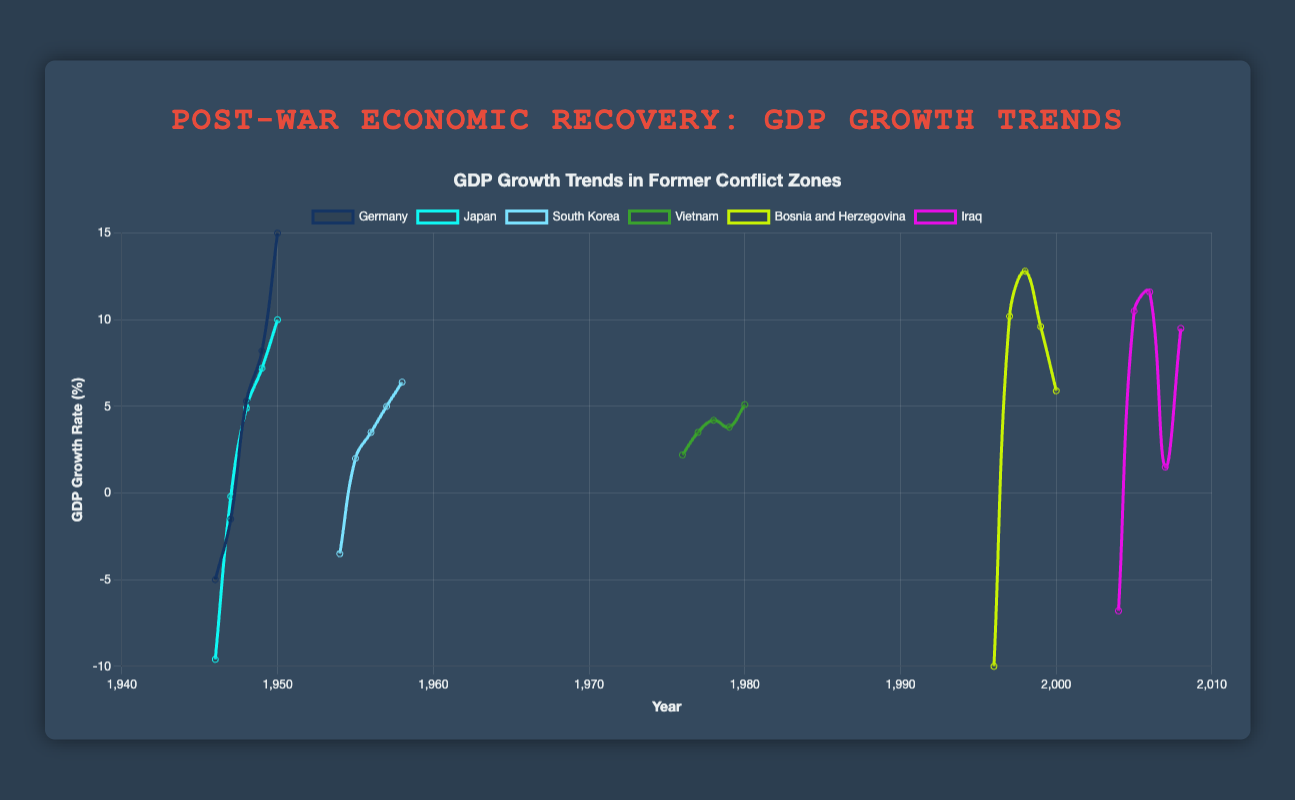Which country had the highest GDP growth rate in 1950? The figure shows the GDP growth rates across different countries over the years. By looking at the data points for 1950, we can see that Germany had the highest GDP growth rate at 15.0%.
Answer: Germany What is the average GDP growth rate of Germany from 1946 to 1950? First, retrieve the GDP growth rates of Germany from 1946 to 1950: -5.0, -1.5, 5.3, 8.2, and 15.0. Sum them up: -5.0 + (-1.5) + 5.3 + 8.2 + 15.0 = 22.0. Divide by the number of years (5) to get the average: 22.0 / 5 = 4.4%.
Answer: 4.4% Which country experienced the most significant recovery from a negative GDP growth rate to a positive one within a year? Looking at the transitions, Bosnia and Herzegovina go from -10.0% in 1996 to 10.2% in 1997, indicating a significant recovery.
Answer: Bosnia and Herzegovina How did Japan’s GDP growth rate change from 1946 to 1947 and how does it compare with the change from 1949 to 1950? The change from 1946 to 1947 was from -9.6% to -0.2%, which is an increase of 9.4% (-0.2 - (-9.6) = 9.4%). From 1949 to 1950, it went from 7.2% to 10.0%, an increase of 2.8% (10.0 - 7.2 = 2.8%). The increase from 1946 to 1947 is more significant.
Answer: 9.4% vs. 2.8% Which country had the lowest GDP growth rate in the entire dataset and what was the rate? By observing the lowest point in the dataset, Bosnia and Herzegovina had the lowest GDP growth rate in 1996 at -10.0%.
Answer: Bosnia and Herzegovina at -10.0% Compare the GDP growth rates of South Korea in 1954 and 1955. Which year had a higher rate and by how much? In 1954, South Korea’s GDP growth rate was -3.5% and in 1955, it was 2.0%. The increase is 5.5% (2.0 - (-3.5) = 5.5%).
Answer: 1955 by 5.5% What’s the overall trend of Vietnam’s GDP growth from 1976 to 1980? Observing the trend for Vietnam from 1976 to 1980, the GDP growth rates are 2.2%, 3.5%, 4.2%, 3.8%, and 5.1%. Despite some fluctuations, the overall trend shows an increase in GDP growth over these years.
Answer: Increasing trend Identify the year with the greatest GDP growth rate for Iraq and specify the rate. Looking at Iraq’s data points, 2006 saw the greatest GDP growth rate at 11.6%.
Answer: 2006 at 11.6% Which country shows the most consistent increase in GDP growth rate over the given years in the dataset? By comparing the trends, South Korea displays a consistent increase from -3.5% in 1954 to 6.4% in 1958 over consecutive years without any decline.
Answer: South Korea 